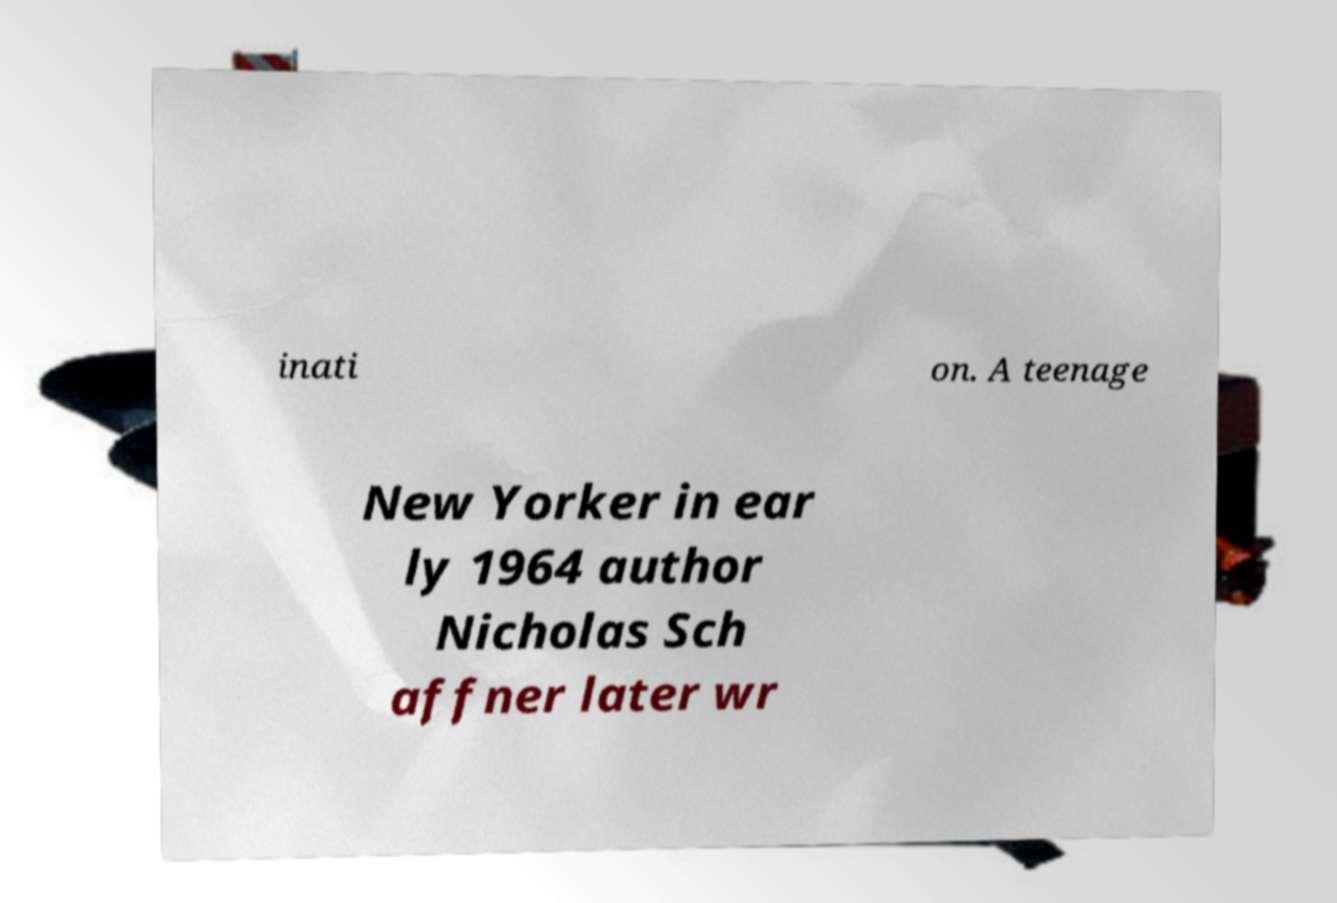Can you accurately transcribe the text from the provided image for me? inati on. A teenage New Yorker in ear ly 1964 author Nicholas Sch affner later wr 